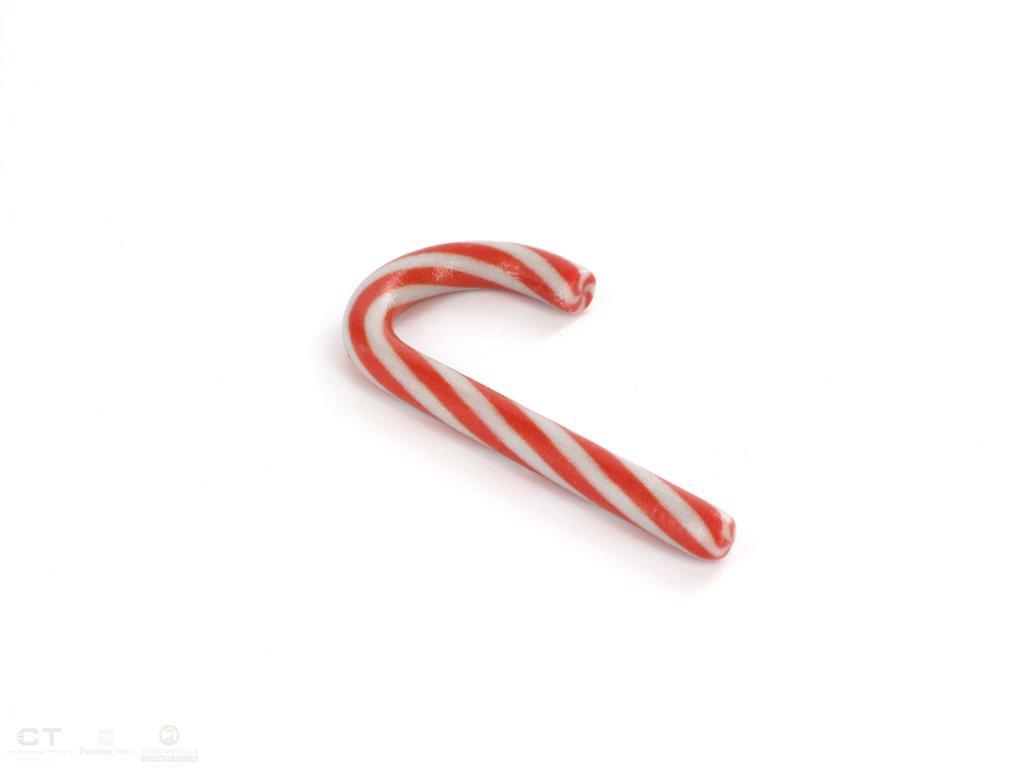Can you describe this image briefly? In this image we can see sugar candy which is in red and white color. 